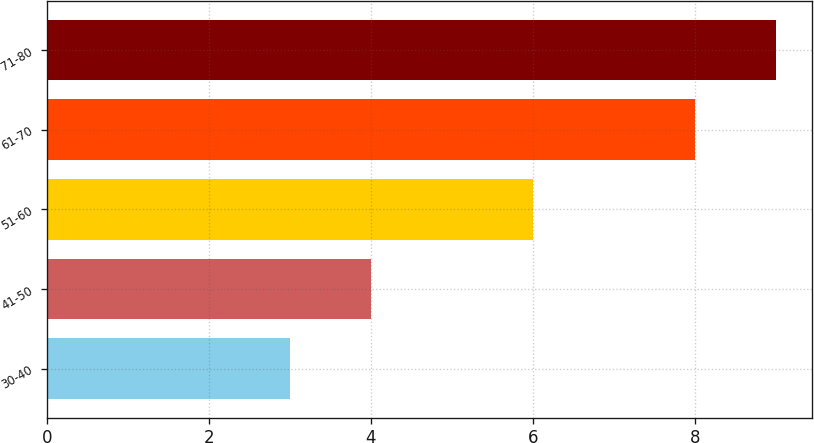Convert chart to OTSL. <chart><loc_0><loc_0><loc_500><loc_500><bar_chart><fcel>30-40<fcel>41-50<fcel>51-60<fcel>61-70<fcel>71-80<nl><fcel>3<fcel>4<fcel>6<fcel>8<fcel>9<nl></chart> 